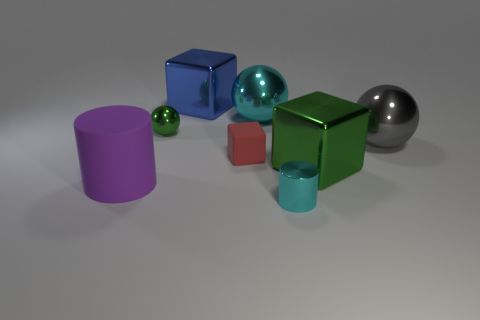What material is the ball that is the same color as the tiny metallic cylinder?
Offer a very short reply. Metal. How many balls have the same color as the tiny cylinder?
Your answer should be compact. 1. There is a matte thing right of the purple object; is it the same color as the big thing that is on the left side of the green ball?
Your answer should be very brief. No. Are there any blue metal blocks behind the gray metal thing?
Offer a very short reply. Yes. What material is the cube that is behind the green shiny block and in front of the tiny green ball?
Keep it short and to the point. Rubber. Are the large thing behind the cyan metallic sphere and the large gray object made of the same material?
Give a very brief answer. Yes. What is the material of the big purple cylinder?
Your answer should be compact. Rubber. There is a metal cube that is on the right side of the tiny cyan thing; what size is it?
Provide a succinct answer. Large. Is there any other thing that has the same color as the large rubber cylinder?
Your answer should be compact. No. Is there a small red cube that is right of the small shiny object in front of the cylinder left of the blue shiny block?
Your answer should be compact. No. 